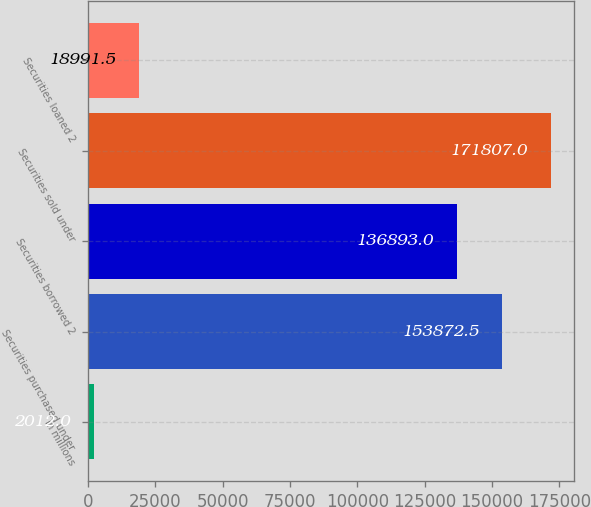Convert chart to OTSL. <chart><loc_0><loc_0><loc_500><loc_500><bar_chart><fcel>in millions<fcel>Securities purchased under<fcel>Securities borrowed 2<fcel>Securities sold under<fcel>Securities loaned 2<nl><fcel>2012<fcel>153872<fcel>136893<fcel>171807<fcel>18991.5<nl></chart> 